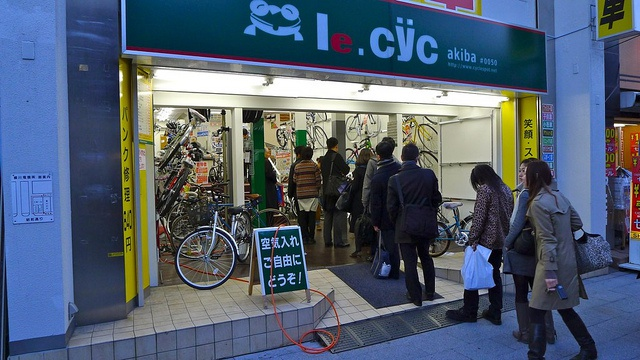Describe the objects in this image and their specific colors. I can see people in gray, black, and darkblue tones, people in gray, black, and darkgray tones, people in gray and black tones, bicycle in gray, black, and darkgray tones, and bicycle in gray, black, and darkgray tones in this image. 